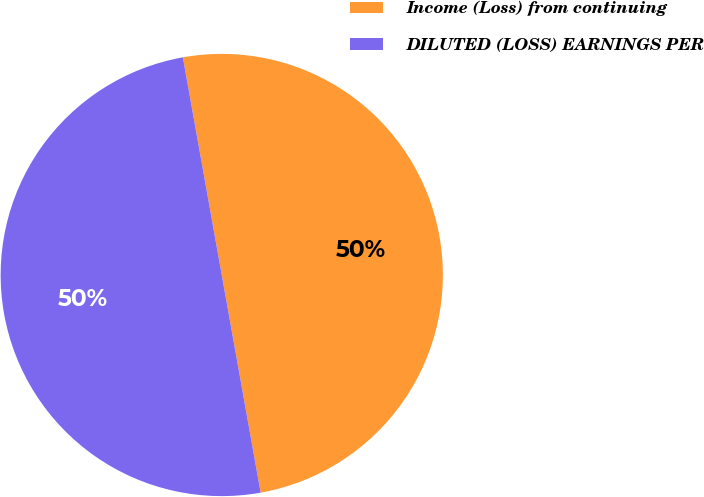Convert chart. <chart><loc_0><loc_0><loc_500><loc_500><pie_chart><fcel>Income (Loss) from continuing<fcel>DILUTED (LOSS) EARNINGS PER<nl><fcel>50.0%<fcel>50.0%<nl></chart> 